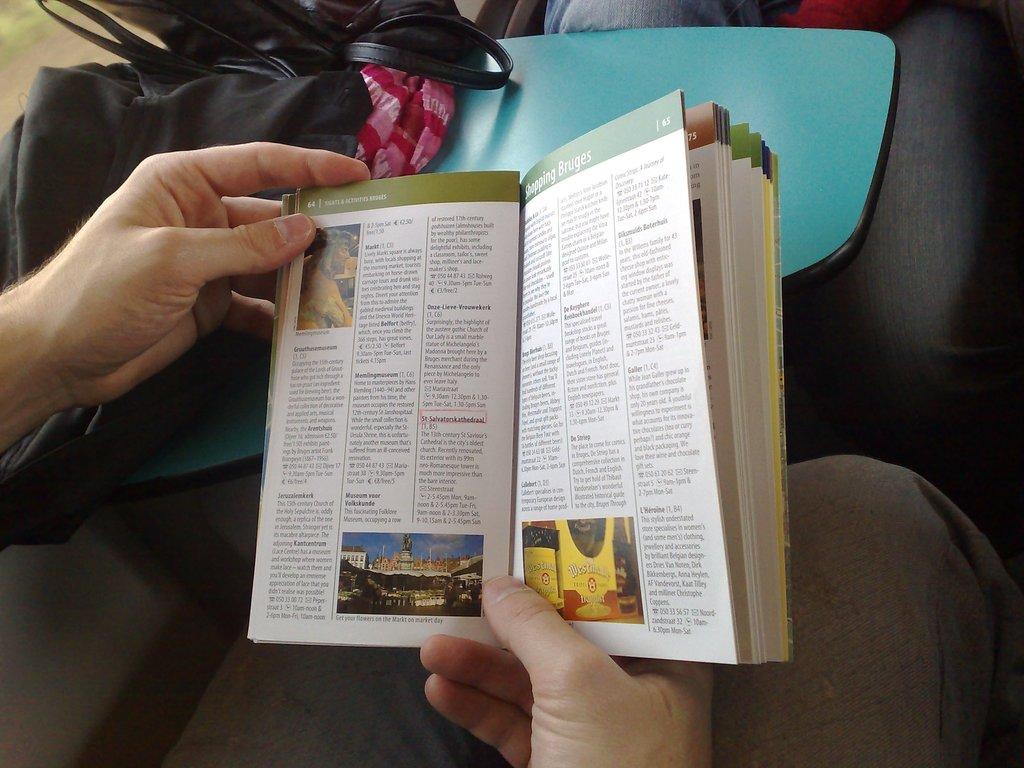What is the left page number?
Provide a succinct answer. 64. 